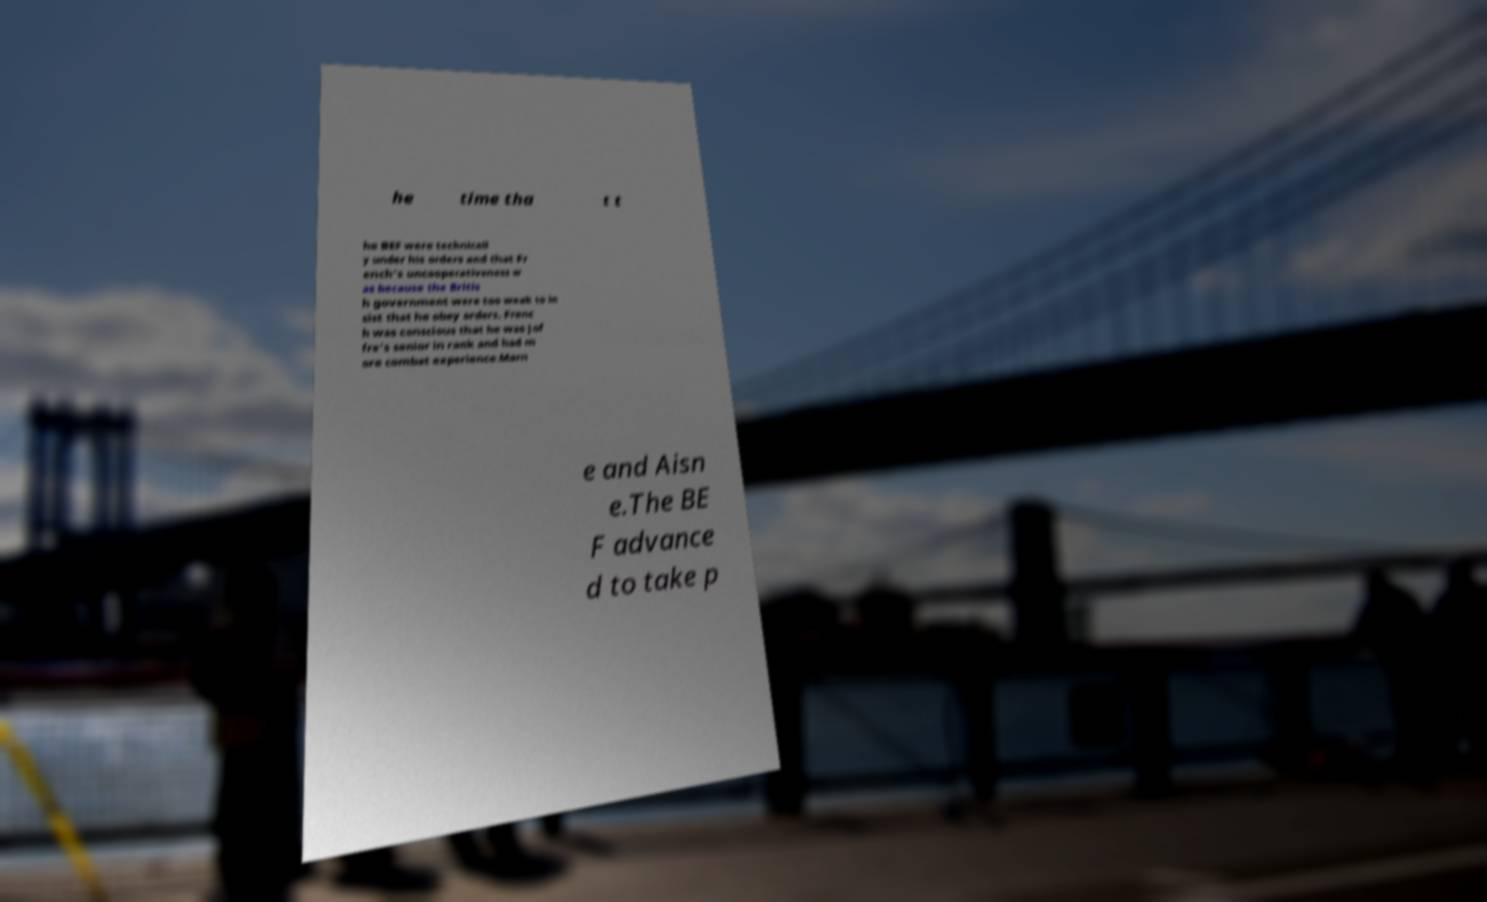Could you assist in decoding the text presented in this image and type it out clearly? he time tha t t he BEF were technicall y under his orders and that Fr ench's uncooperativeness w as because the Britis h government were too weak to in sist that he obey orders. Frenc h was conscious that he was Jof fre's senior in rank and had m ore combat experience.Marn e and Aisn e.The BE F advance d to take p 